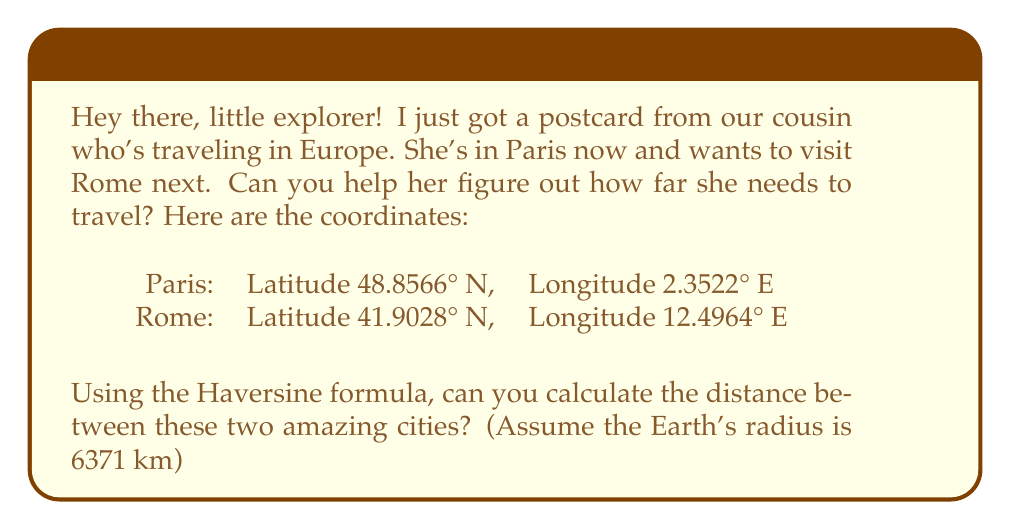Teach me how to tackle this problem. Great question! Let's solve this step-by-step using the Haversine formula. This formula is perfect for calculating distances between two points on a sphere (like our Earth) using their latitude and longitude.

Step 1: Convert the coordinates from degrees to radians.
Paris: $\text{lat}_1 = 48.8566° \times \frac{\pi}{180} = 0.8527$ rad
       $\text{lon}_1 = 2.3522° \times \frac{\pi}{180} = 0.0411$ rad
Rome: $\text{lat}_2 = 41.9028° \times \frac{\pi}{180} = 0.7312$ rad
      $\text{lon}_2 = 12.4964° \times \frac{\pi}{180} = 0.2181$ rad

Step 2: Calculate the difference in longitude.
$\Delta\text{lon} = \text{lon}_2 - \text{lon}_1 = 0.2181 - 0.0411 = 0.1770$ rad

Step 3: Apply the Haversine formula:
$$d = 2r \times \arcsin\left(\sqrt{\sin^2\left(\frac{\text{lat}_2 - \text{lat}_1}{2}\right) + \cos(\text{lat}_1)\cos(\text{lat}_2)\sin^2\left(\frac{\Delta\text{lon}}{2}\right)}\right)$$

Where $r$ is the Earth's radius (6371 km).

Let's break this down:
a) $\sin^2\left(\frac{\text{lat}_2 - \text{lat}_1}{2}\right) = \sin^2\left(\frac{0.7312 - 0.8527}{2}\right) = 0.0018$

b) $\cos(\text{lat}_1)\cos(\text{lat}_2) = \cos(0.8527)\cos(0.7312) = 0.5464$

c) $\sin^2\left(\frac{\Delta\text{lon}}{2}\right) = \sin^2\left(\frac{0.1770}{2}\right) = 0.0078$

d) Inside the square root: $0.0018 + 0.5464 \times 0.0078 = 0.0061$

e) $\sqrt{0.0061} = 0.0781$

f) $\arcsin(0.0781) = 0.0782$

Step 4: Calculate the final distance:
$d = 2 \times 6371 \times 0.0782 = 996.4$ km

Therefore, the distance between Paris and Rome is approximately 996.4 km.
Answer: The distance between Paris and Rome is approximately 996.4 km. 